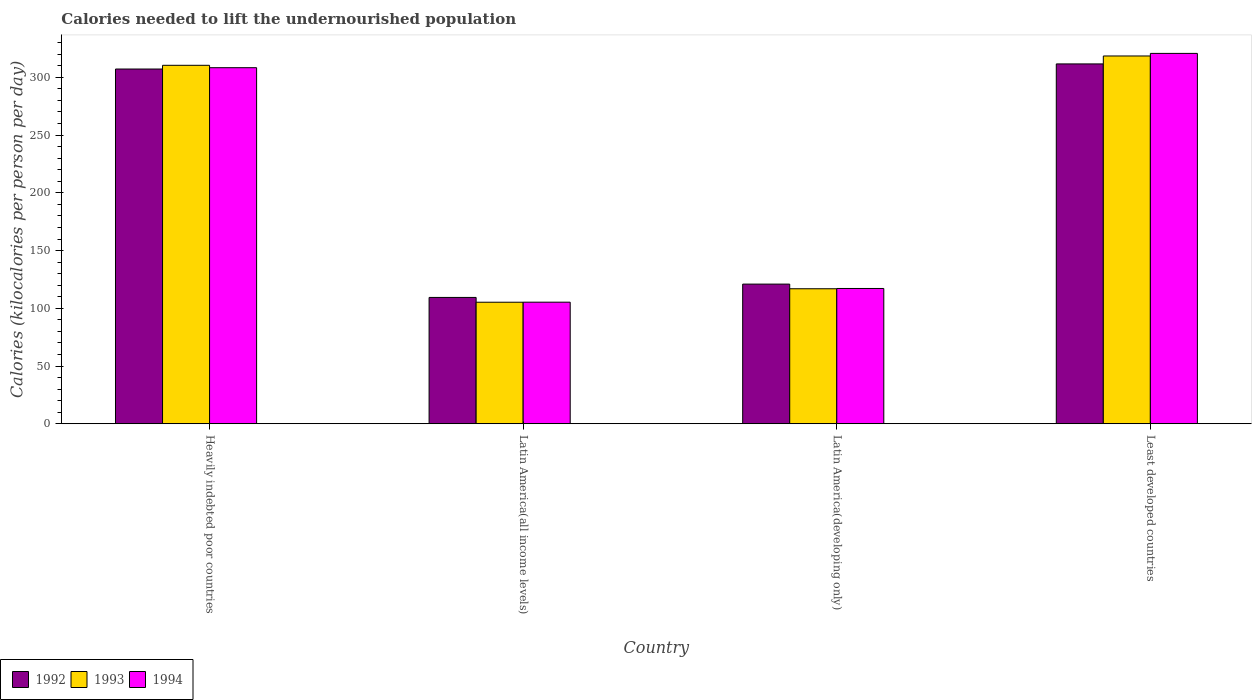How many bars are there on the 1st tick from the right?
Your answer should be very brief. 3. What is the label of the 1st group of bars from the left?
Offer a very short reply. Heavily indebted poor countries. In how many cases, is the number of bars for a given country not equal to the number of legend labels?
Your response must be concise. 0. What is the total calories needed to lift the undernourished population in 1993 in Least developed countries?
Offer a terse response. 318.52. Across all countries, what is the maximum total calories needed to lift the undernourished population in 1993?
Offer a very short reply. 318.52. Across all countries, what is the minimum total calories needed to lift the undernourished population in 1992?
Offer a terse response. 109.39. In which country was the total calories needed to lift the undernourished population in 1993 maximum?
Offer a very short reply. Least developed countries. In which country was the total calories needed to lift the undernourished population in 1994 minimum?
Your answer should be compact. Latin America(all income levels). What is the total total calories needed to lift the undernourished population in 1992 in the graph?
Your answer should be compact. 849.2. What is the difference between the total calories needed to lift the undernourished population in 1992 in Latin America(all income levels) and that in Latin America(developing only)?
Keep it short and to the point. -11.55. What is the difference between the total calories needed to lift the undernourished population in 1992 in Latin America(all income levels) and the total calories needed to lift the undernourished population in 1993 in Heavily indebted poor countries?
Offer a terse response. -201.06. What is the average total calories needed to lift the undernourished population in 1993 per country?
Provide a short and direct response. 212.78. What is the difference between the total calories needed to lift the undernourished population of/in 1993 and total calories needed to lift the undernourished population of/in 1992 in Latin America(all income levels)?
Provide a succinct answer. -4.14. What is the ratio of the total calories needed to lift the undernourished population in 1994 in Latin America(all income levels) to that in Least developed countries?
Ensure brevity in your answer.  0.33. What is the difference between the highest and the second highest total calories needed to lift the undernourished population in 1994?
Offer a very short reply. 12.39. What is the difference between the highest and the lowest total calories needed to lift the undernourished population in 1994?
Provide a short and direct response. 215.48. In how many countries, is the total calories needed to lift the undernourished population in 1994 greater than the average total calories needed to lift the undernourished population in 1994 taken over all countries?
Give a very brief answer. 2. Is the sum of the total calories needed to lift the undernourished population in 1994 in Heavily indebted poor countries and Latin America(developing only) greater than the maximum total calories needed to lift the undernourished population in 1993 across all countries?
Offer a terse response. Yes. What does the 3rd bar from the left in Latin America(all income levels) represents?
Keep it short and to the point. 1994. How many bars are there?
Offer a terse response. 12. Does the graph contain any zero values?
Offer a terse response. No. Does the graph contain grids?
Your answer should be very brief. No. Where does the legend appear in the graph?
Your answer should be very brief. Bottom left. How many legend labels are there?
Your response must be concise. 3. What is the title of the graph?
Give a very brief answer. Calories needed to lift the undernourished population. What is the label or title of the Y-axis?
Provide a succinct answer. Calories (kilocalories per person per day). What is the Calories (kilocalories per person per day) of 1992 in Heavily indebted poor countries?
Provide a short and direct response. 307.23. What is the Calories (kilocalories per person per day) in 1993 in Heavily indebted poor countries?
Your answer should be compact. 310.45. What is the Calories (kilocalories per person per day) of 1994 in Heavily indebted poor countries?
Ensure brevity in your answer.  308.37. What is the Calories (kilocalories per person per day) of 1992 in Latin America(all income levels)?
Provide a short and direct response. 109.39. What is the Calories (kilocalories per person per day) of 1993 in Latin America(all income levels)?
Give a very brief answer. 105.25. What is the Calories (kilocalories per person per day) in 1994 in Latin America(all income levels)?
Make the answer very short. 105.28. What is the Calories (kilocalories per person per day) of 1992 in Latin America(developing only)?
Provide a succinct answer. 120.94. What is the Calories (kilocalories per person per day) in 1993 in Latin America(developing only)?
Your response must be concise. 116.91. What is the Calories (kilocalories per person per day) in 1994 in Latin America(developing only)?
Offer a terse response. 117.15. What is the Calories (kilocalories per person per day) of 1992 in Least developed countries?
Offer a terse response. 311.64. What is the Calories (kilocalories per person per day) of 1993 in Least developed countries?
Provide a short and direct response. 318.52. What is the Calories (kilocalories per person per day) in 1994 in Least developed countries?
Provide a short and direct response. 320.76. Across all countries, what is the maximum Calories (kilocalories per person per day) of 1992?
Your answer should be compact. 311.64. Across all countries, what is the maximum Calories (kilocalories per person per day) in 1993?
Provide a succinct answer. 318.52. Across all countries, what is the maximum Calories (kilocalories per person per day) of 1994?
Give a very brief answer. 320.76. Across all countries, what is the minimum Calories (kilocalories per person per day) in 1992?
Provide a succinct answer. 109.39. Across all countries, what is the minimum Calories (kilocalories per person per day) in 1993?
Keep it short and to the point. 105.25. Across all countries, what is the minimum Calories (kilocalories per person per day) of 1994?
Your response must be concise. 105.28. What is the total Calories (kilocalories per person per day) of 1992 in the graph?
Offer a very short reply. 849.2. What is the total Calories (kilocalories per person per day) in 1993 in the graph?
Your answer should be compact. 851.12. What is the total Calories (kilocalories per person per day) of 1994 in the graph?
Your answer should be compact. 851.55. What is the difference between the Calories (kilocalories per person per day) of 1992 in Heavily indebted poor countries and that in Latin America(all income levels)?
Your answer should be compact. 197.84. What is the difference between the Calories (kilocalories per person per day) in 1993 in Heavily indebted poor countries and that in Latin America(all income levels)?
Offer a very short reply. 205.2. What is the difference between the Calories (kilocalories per person per day) of 1994 in Heavily indebted poor countries and that in Latin America(all income levels)?
Your answer should be compact. 203.09. What is the difference between the Calories (kilocalories per person per day) of 1992 in Heavily indebted poor countries and that in Latin America(developing only)?
Your answer should be compact. 186.28. What is the difference between the Calories (kilocalories per person per day) of 1993 in Heavily indebted poor countries and that in Latin America(developing only)?
Provide a short and direct response. 193.53. What is the difference between the Calories (kilocalories per person per day) of 1994 in Heavily indebted poor countries and that in Latin America(developing only)?
Ensure brevity in your answer.  191.22. What is the difference between the Calories (kilocalories per person per day) of 1992 in Heavily indebted poor countries and that in Least developed countries?
Your response must be concise. -4.42. What is the difference between the Calories (kilocalories per person per day) of 1993 in Heavily indebted poor countries and that in Least developed countries?
Offer a terse response. -8.07. What is the difference between the Calories (kilocalories per person per day) of 1994 in Heavily indebted poor countries and that in Least developed countries?
Provide a succinct answer. -12.39. What is the difference between the Calories (kilocalories per person per day) of 1992 in Latin America(all income levels) and that in Latin America(developing only)?
Make the answer very short. -11.55. What is the difference between the Calories (kilocalories per person per day) of 1993 in Latin America(all income levels) and that in Latin America(developing only)?
Your answer should be compact. -11.66. What is the difference between the Calories (kilocalories per person per day) of 1994 in Latin America(all income levels) and that in Latin America(developing only)?
Keep it short and to the point. -11.87. What is the difference between the Calories (kilocalories per person per day) in 1992 in Latin America(all income levels) and that in Least developed countries?
Your answer should be very brief. -202.25. What is the difference between the Calories (kilocalories per person per day) in 1993 in Latin America(all income levels) and that in Least developed countries?
Make the answer very short. -213.27. What is the difference between the Calories (kilocalories per person per day) in 1994 in Latin America(all income levels) and that in Least developed countries?
Provide a short and direct response. -215.48. What is the difference between the Calories (kilocalories per person per day) of 1992 in Latin America(developing only) and that in Least developed countries?
Ensure brevity in your answer.  -190.7. What is the difference between the Calories (kilocalories per person per day) in 1993 in Latin America(developing only) and that in Least developed countries?
Your answer should be very brief. -201.61. What is the difference between the Calories (kilocalories per person per day) of 1994 in Latin America(developing only) and that in Least developed countries?
Provide a succinct answer. -203.61. What is the difference between the Calories (kilocalories per person per day) of 1992 in Heavily indebted poor countries and the Calories (kilocalories per person per day) of 1993 in Latin America(all income levels)?
Offer a terse response. 201.98. What is the difference between the Calories (kilocalories per person per day) of 1992 in Heavily indebted poor countries and the Calories (kilocalories per person per day) of 1994 in Latin America(all income levels)?
Provide a succinct answer. 201.95. What is the difference between the Calories (kilocalories per person per day) of 1993 in Heavily indebted poor countries and the Calories (kilocalories per person per day) of 1994 in Latin America(all income levels)?
Your answer should be very brief. 205.17. What is the difference between the Calories (kilocalories per person per day) of 1992 in Heavily indebted poor countries and the Calories (kilocalories per person per day) of 1993 in Latin America(developing only)?
Provide a short and direct response. 190.32. What is the difference between the Calories (kilocalories per person per day) in 1992 in Heavily indebted poor countries and the Calories (kilocalories per person per day) in 1994 in Latin America(developing only)?
Give a very brief answer. 190.08. What is the difference between the Calories (kilocalories per person per day) of 1993 in Heavily indebted poor countries and the Calories (kilocalories per person per day) of 1994 in Latin America(developing only)?
Your response must be concise. 193.3. What is the difference between the Calories (kilocalories per person per day) of 1992 in Heavily indebted poor countries and the Calories (kilocalories per person per day) of 1993 in Least developed countries?
Provide a succinct answer. -11.29. What is the difference between the Calories (kilocalories per person per day) of 1992 in Heavily indebted poor countries and the Calories (kilocalories per person per day) of 1994 in Least developed countries?
Your response must be concise. -13.53. What is the difference between the Calories (kilocalories per person per day) of 1993 in Heavily indebted poor countries and the Calories (kilocalories per person per day) of 1994 in Least developed countries?
Offer a terse response. -10.31. What is the difference between the Calories (kilocalories per person per day) of 1992 in Latin America(all income levels) and the Calories (kilocalories per person per day) of 1993 in Latin America(developing only)?
Provide a short and direct response. -7.52. What is the difference between the Calories (kilocalories per person per day) of 1992 in Latin America(all income levels) and the Calories (kilocalories per person per day) of 1994 in Latin America(developing only)?
Give a very brief answer. -7.76. What is the difference between the Calories (kilocalories per person per day) of 1993 in Latin America(all income levels) and the Calories (kilocalories per person per day) of 1994 in Latin America(developing only)?
Your answer should be very brief. -11.9. What is the difference between the Calories (kilocalories per person per day) of 1992 in Latin America(all income levels) and the Calories (kilocalories per person per day) of 1993 in Least developed countries?
Provide a short and direct response. -209.13. What is the difference between the Calories (kilocalories per person per day) of 1992 in Latin America(all income levels) and the Calories (kilocalories per person per day) of 1994 in Least developed countries?
Offer a very short reply. -211.37. What is the difference between the Calories (kilocalories per person per day) in 1993 in Latin America(all income levels) and the Calories (kilocalories per person per day) in 1994 in Least developed countries?
Offer a very short reply. -215.51. What is the difference between the Calories (kilocalories per person per day) of 1992 in Latin America(developing only) and the Calories (kilocalories per person per day) of 1993 in Least developed countries?
Give a very brief answer. -197.58. What is the difference between the Calories (kilocalories per person per day) in 1992 in Latin America(developing only) and the Calories (kilocalories per person per day) in 1994 in Least developed countries?
Make the answer very short. -199.82. What is the difference between the Calories (kilocalories per person per day) of 1993 in Latin America(developing only) and the Calories (kilocalories per person per day) of 1994 in Least developed countries?
Offer a terse response. -203.85. What is the average Calories (kilocalories per person per day) of 1992 per country?
Offer a terse response. 212.3. What is the average Calories (kilocalories per person per day) of 1993 per country?
Provide a short and direct response. 212.78. What is the average Calories (kilocalories per person per day) of 1994 per country?
Provide a succinct answer. 212.89. What is the difference between the Calories (kilocalories per person per day) of 1992 and Calories (kilocalories per person per day) of 1993 in Heavily indebted poor countries?
Offer a terse response. -3.22. What is the difference between the Calories (kilocalories per person per day) in 1992 and Calories (kilocalories per person per day) in 1994 in Heavily indebted poor countries?
Your response must be concise. -1.14. What is the difference between the Calories (kilocalories per person per day) of 1993 and Calories (kilocalories per person per day) of 1994 in Heavily indebted poor countries?
Your response must be concise. 2.08. What is the difference between the Calories (kilocalories per person per day) of 1992 and Calories (kilocalories per person per day) of 1993 in Latin America(all income levels)?
Your answer should be compact. 4.14. What is the difference between the Calories (kilocalories per person per day) in 1992 and Calories (kilocalories per person per day) in 1994 in Latin America(all income levels)?
Give a very brief answer. 4.11. What is the difference between the Calories (kilocalories per person per day) in 1993 and Calories (kilocalories per person per day) in 1994 in Latin America(all income levels)?
Give a very brief answer. -0.03. What is the difference between the Calories (kilocalories per person per day) in 1992 and Calories (kilocalories per person per day) in 1993 in Latin America(developing only)?
Provide a succinct answer. 4.03. What is the difference between the Calories (kilocalories per person per day) in 1992 and Calories (kilocalories per person per day) in 1994 in Latin America(developing only)?
Your response must be concise. 3.8. What is the difference between the Calories (kilocalories per person per day) of 1993 and Calories (kilocalories per person per day) of 1994 in Latin America(developing only)?
Ensure brevity in your answer.  -0.23. What is the difference between the Calories (kilocalories per person per day) in 1992 and Calories (kilocalories per person per day) in 1993 in Least developed countries?
Your answer should be compact. -6.87. What is the difference between the Calories (kilocalories per person per day) of 1992 and Calories (kilocalories per person per day) of 1994 in Least developed countries?
Keep it short and to the point. -9.11. What is the difference between the Calories (kilocalories per person per day) of 1993 and Calories (kilocalories per person per day) of 1994 in Least developed countries?
Ensure brevity in your answer.  -2.24. What is the ratio of the Calories (kilocalories per person per day) in 1992 in Heavily indebted poor countries to that in Latin America(all income levels)?
Ensure brevity in your answer.  2.81. What is the ratio of the Calories (kilocalories per person per day) of 1993 in Heavily indebted poor countries to that in Latin America(all income levels)?
Provide a short and direct response. 2.95. What is the ratio of the Calories (kilocalories per person per day) in 1994 in Heavily indebted poor countries to that in Latin America(all income levels)?
Your response must be concise. 2.93. What is the ratio of the Calories (kilocalories per person per day) of 1992 in Heavily indebted poor countries to that in Latin America(developing only)?
Ensure brevity in your answer.  2.54. What is the ratio of the Calories (kilocalories per person per day) of 1993 in Heavily indebted poor countries to that in Latin America(developing only)?
Your response must be concise. 2.66. What is the ratio of the Calories (kilocalories per person per day) of 1994 in Heavily indebted poor countries to that in Latin America(developing only)?
Provide a succinct answer. 2.63. What is the ratio of the Calories (kilocalories per person per day) of 1992 in Heavily indebted poor countries to that in Least developed countries?
Offer a terse response. 0.99. What is the ratio of the Calories (kilocalories per person per day) of 1993 in Heavily indebted poor countries to that in Least developed countries?
Give a very brief answer. 0.97. What is the ratio of the Calories (kilocalories per person per day) in 1994 in Heavily indebted poor countries to that in Least developed countries?
Make the answer very short. 0.96. What is the ratio of the Calories (kilocalories per person per day) of 1992 in Latin America(all income levels) to that in Latin America(developing only)?
Give a very brief answer. 0.9. What is the ratio of the Calories (kilocalories per person per day) of 1993 in Latin America(all income levels) to that in Latin America(developing only)?
Provide a succinct answer. 0.9. What is the ratio of the Calories (kilocalories per person per day) in 1994 in Latin America(all income levels) to that in Latin America(developing only)?
Provide a short and direct response. 0.9. What is the ratio of the Calories (kilocalories per person per day) in 1992 in Latin America(all income levels) to that in Least developed countries?
Offer a very short reply. 0.35. What is the ratio of the Calories (kilocalories per person per day) of 1993 in Latin America(all income levels) to that in Least developed countries?
Provide a succinct answer. 0.33. What is the ratio of the Calories (kilocalories per person per day) in 1994 in Latin America(all income levels) to that in Least developed countries?
Make the answer very short. 0.33. What is the ratio of the Calories (kilocalories per person per day) in 1992 in Latin America(developing only) to that in Least developed countries?
Keep it short and to the point. 0.39. What is the ratio of the Calories (kilocalories per person per day) in 1993 in Latin America(developing only) to that in Least developed countries?
Your answer should be compact. 0.37. What is the ratio of the Calories (kilocalories per person per day) of 1994 in Latin America(developing only) to that in Least developed countries?
Ensure brevity in your answer.  0.37. What is the difference between the highest and the second highest Calories (kilocalories per person per day) in 1992?
Give a very brief answer. 4.42. What is the difference between the highest and the second highest Calories (kilocalories per person per day) in 1993?
Your answer should be compact. 8.07. What is the difference between the highest and the second highest Calories (kilocalories per person per day) of 1994?
Your answer should be compact. 12.39. What is the difference between the highest and the lowest Calories (kilocalories per person per day) of 1992?
Make the answer very short. 202.25. What is the difference between the highest and the lowest Calories (kilocalories per person per day) of 1993?
Ensure brevity in your answer.  213.27. What is the difference between the highest and the lowest Calories (kilocalories per person per day) of 1994?
Give a very brief answer. 215.48. 